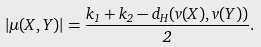Convert formula to latex. <formula><loc_0><loc_0><loc_500><loc_500>| \mu ( X , Y ) | = \frac { k _ { 1 } + k _ { 2 } - d _ { H } ( v ( X ) , v ( Y ) ) } { 2 } .</formula> 